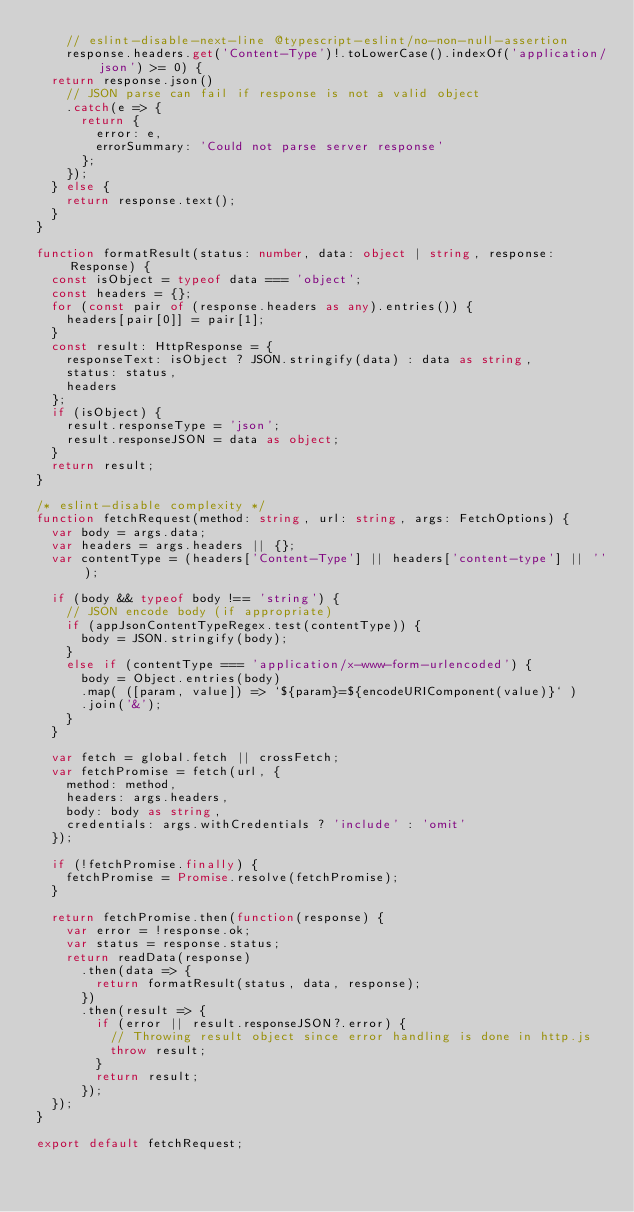<code> <loc_0><loc_0><loc_500><loc_500><_TypeScript_>    // eslint-disable-next-line @typescript-eslint/no-non-null-assertion
    response.headers.get('Content-Type')!.toLowerCase().indexOf('application/json') >= 0) {
  return response.json()
    // JSON parse can fail if response is not a valid object
    .catch(e => {
      return {
        error: e,
        errorSummary: 'Could not parse server response'
      };
    });
  } else {
    return response.text();
  }
}

function formatResult(status: number, data: object | string, response: Response) {
  const isObject = typeof data === 'object';
  const headers = {};
  for (const pair of (response.headers as any).entries()) {
    headers[pair[0]] = pair[1];
  }
  const result: HttpResponse = {
    responseText: isObject ? JSON.stringify(data) : data as string,
    status: status,
    headers
  };
  if (isObject) {
    result.responseType = 'json';
    result.responseJSON = data as object;
  }
  return result;
}

/* eslint-disable complexity */
function fetchRequest(method: string, url: string, args: FetchOptions) {
  var body = args.data;
  var headers = args.headers || {};
  var contentType = (headers['Content-Type'] || headers['content-type'] || '');

  if (body && typeof body !== 'string') {
    // JSON encode body (if appropriate)
    if (appJsonContentTypeRegex.test(contentType)) {
      body = JSON.stringify(body);
    }
    else if (contentType === 'application/x-www-form-urlencoded') {
      body = Object.entries(body)
      .map( ([param, value]) => `${param}=${encodeURIComponent(value)}` )
      .join('&');
    }
  }

  var fetch = global.fetch || crossFetch;
  var fetchPromise = fetch(url, {
    method: method,
    headers: args.headers,
    body: body as string,
    credentials: args.withCredentials ? 'include' : 'omit'
  });

  if (!fetchPromise.finally) {
    fetchPromise = Promise.resolve(fetchPromise);
  }

  return fetchPromise.then(function(response) {
    var error = !response.ok;
    var status = response.status;
    return readData(response)
      .then(data => {
        return formatResult(status, data, response);
      })
      .then(result => {
        if (error || result.responseJSON?.error) {
          // Throwing result object since error handling is done in http.js
          throw result;
        }
        return result;
      });
  });
}

export default fetchRequest;
</code> 